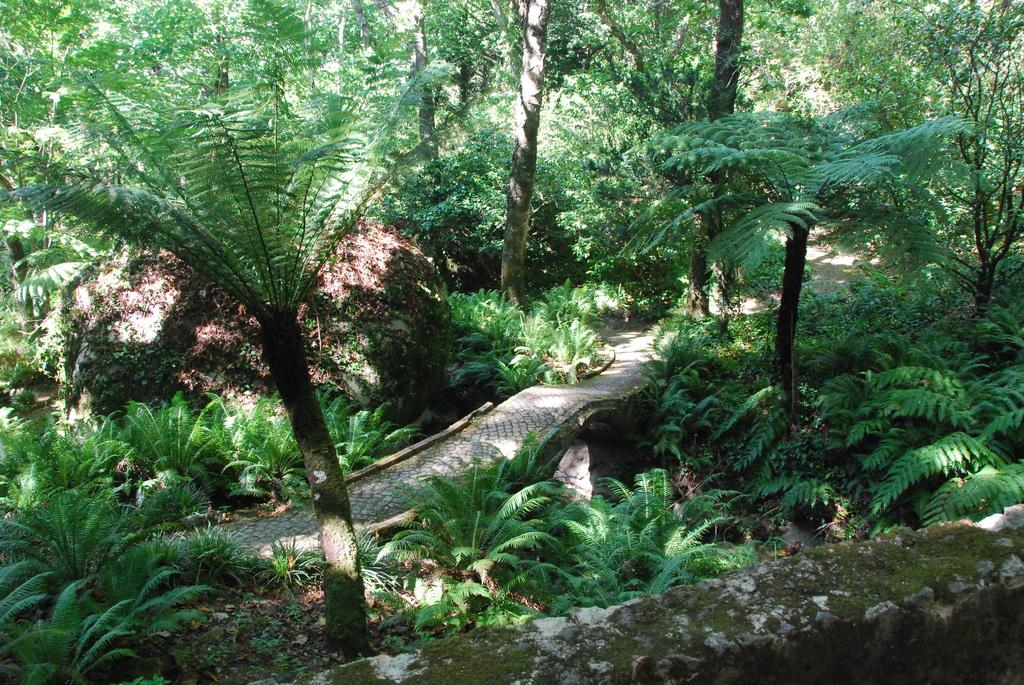What type of vegetation can be seen in the image? There are trees and plants in the image. What is the condition of the leaves on the trees and plants? Dried leaves are present in the image. Is there any indication of a path or walkway in the image? Yes, there is a path visible in the image. What type of powder can be seen covering the trees in the image? There is no powder visible on the trees in the image; they are covered with dried leaves. How does the anger of the bees affect the plants in the image? There are no bees present in the image, so their anger cannot affect the plants. 